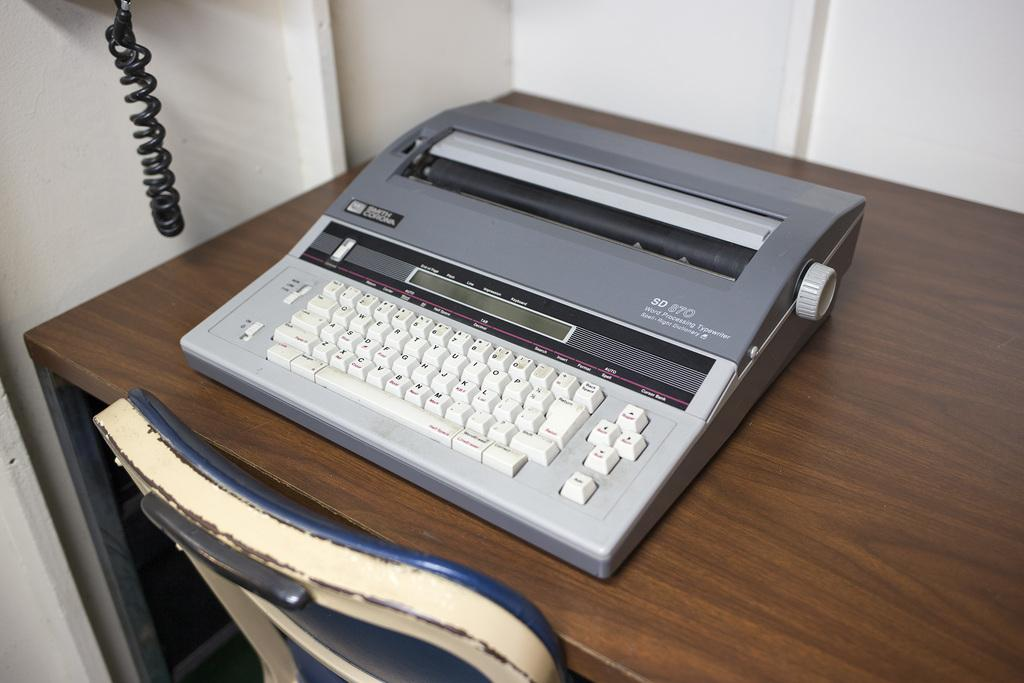<image>
Provide a brief description of the given image. An SD 870 Word Processing Typewriter sits on a desk. 